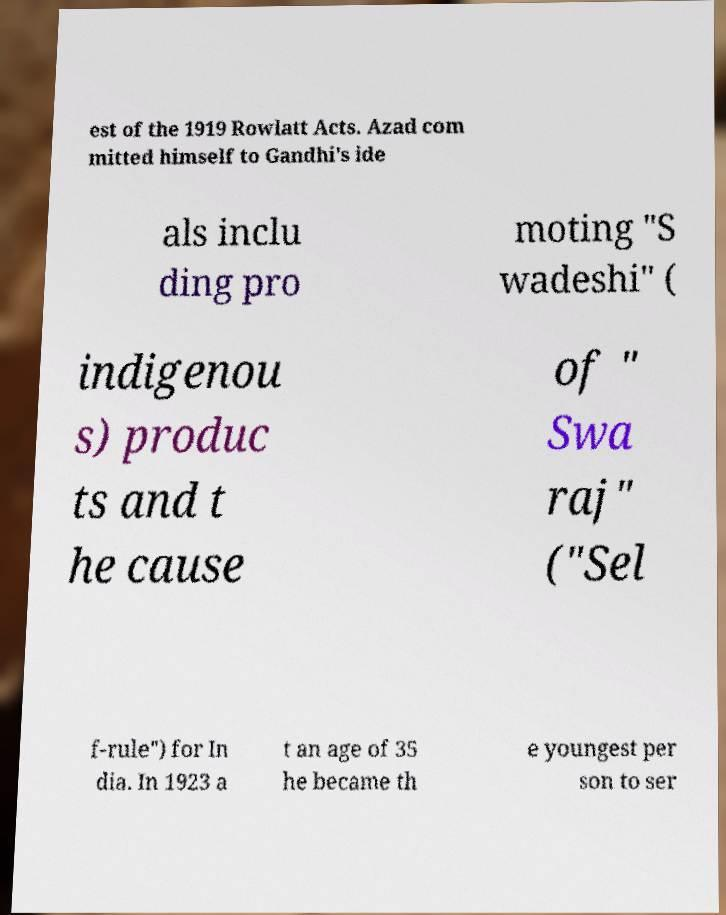Please identify and transcribe the text found in this image. est of the 1919 Rowlatt Acts. Azad com mitted himself to Gandhi's ide als inclu ding pro moting "S wadeshi" ( indigenou s) produc ts and t he cause of " Swa raj" ("Sel f-rule") for In dia. In 1923 a t an age of 35 he became th e youngest per son to ser 